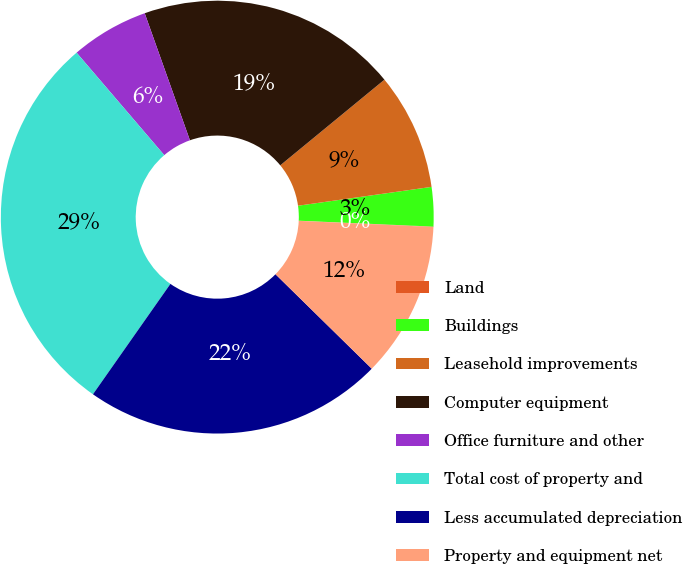Convert chart. <chart><loc_0><loc_0><loc_500><loc_500><pie_chart><fcel>Land<fcel>Buildings<fcel>Leasehold improvements<fcel>Computer equipment<fcel>Office furniture and other<fcel>Total cost of property and<fcel>Less accumulated depreciation<fcel>Property and equipment net<nl><fcel>0.03%<fcel>2.93%<fcel>8.72%<fcel>19.49%<fcel>5.82%<fcel>29.0%<fcel>22.39%<fcel>11.62%<nl></chart> 